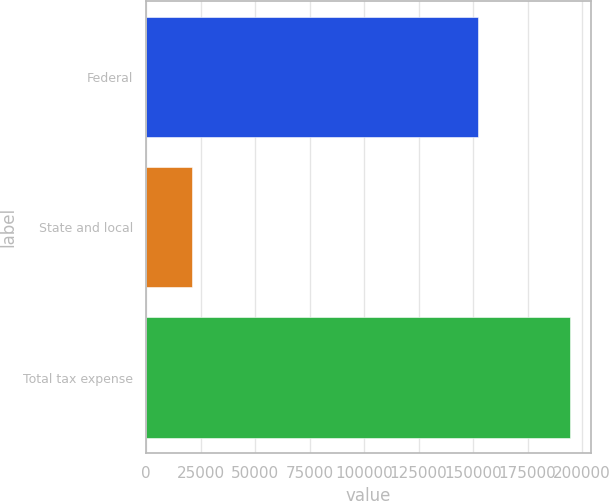Convert chart to OTSL. <chart><loc_0><loc_0><loc_500><loc_500><bar_chart><fcel>Federal<fcel>State and local<fcel>Total tax expense<nl><fcel>152397<fcel>21095<fcel>194287<nl></chart> 